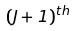<formula> <loc_0><loc_0><loc_500><loc_500>( J + 1 ) ^ { t h }</formula> 